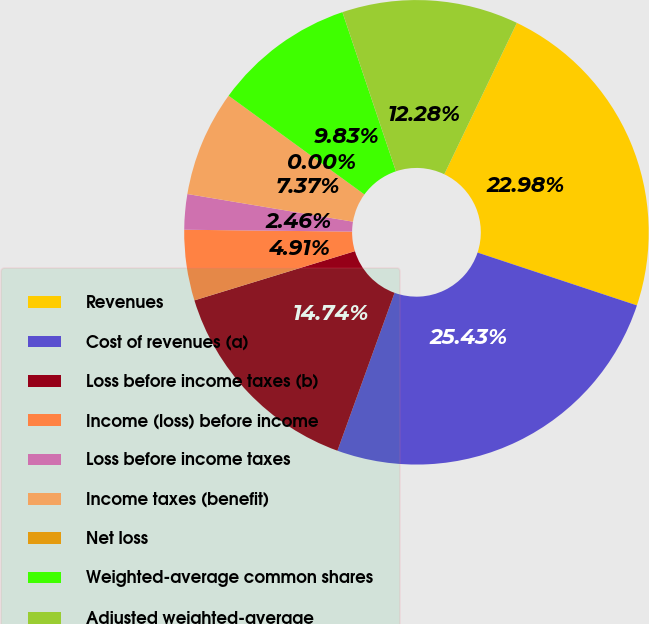Convert chart. <chart><loc_0><loc_0><loc_500><loc_500><pie_chart><fcel>Revenues<fcel>Cost of revenues (a)<fcel>Loss before income taxes (b)<fcel>Income (loss) before income<fcel>Loss before income taxes<fcel>Income taxes (benefit)<fcel>Net loss<fcel>Weighted-average common shares<fcel>Adjusted weighted-average<nl><fcel>22.98%<fcel>25.43%<fcel>14.74%<fcel>4.91%<fcel>2.46%<fcel>7.37%<fcel>0.0%<fcel>9.83%<fcel>12.28%<nl></chart> 